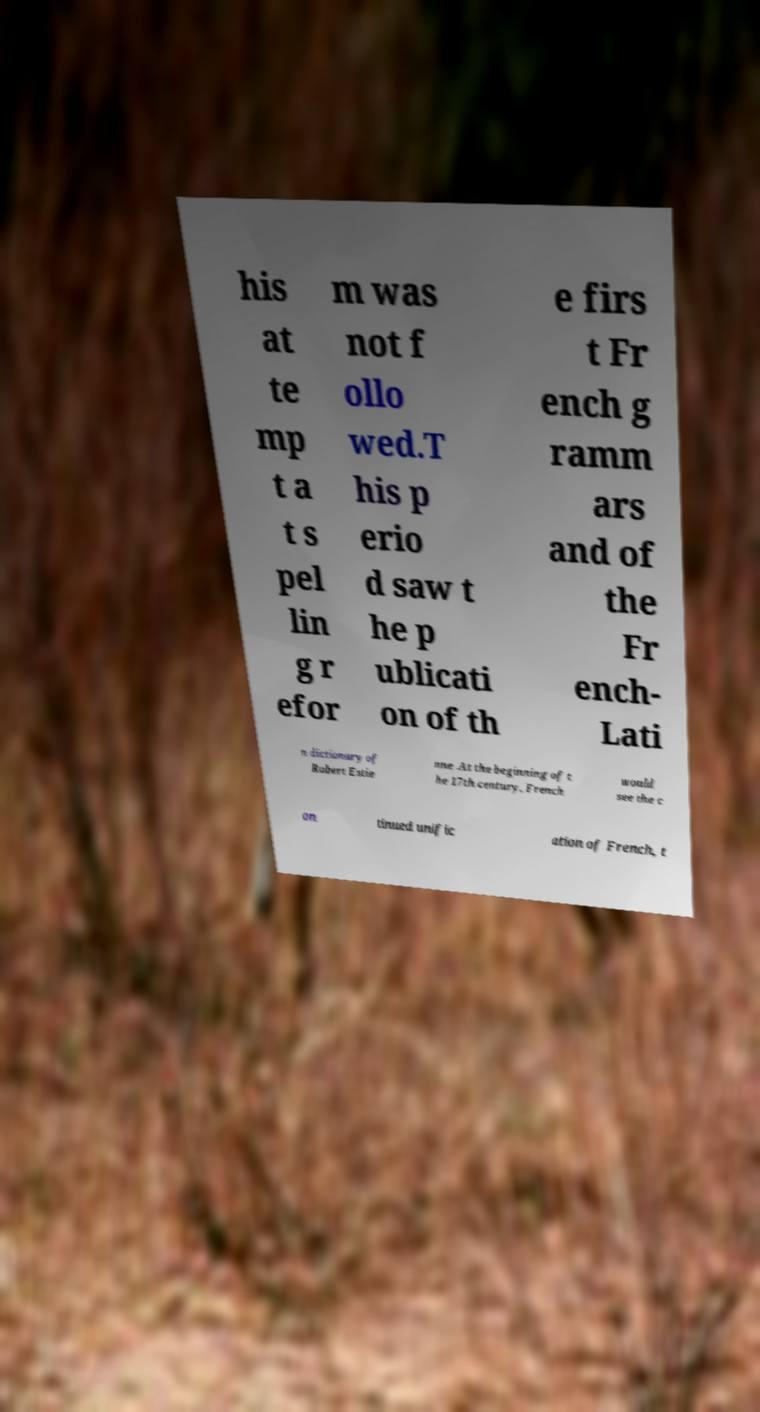Please read and relay the text visible in this image. What does it say? his at te mp t a t s pel lin g r efor m was not f ollo wed.T his p erio d saw t he p ublicati on of th e firs t Fr ench g ramm ars and of the Fr ench- Lati n dictionary of Robert Estie nne .At the beginning of t he 17th century, French would see the c on tinued unific ation of French, t 